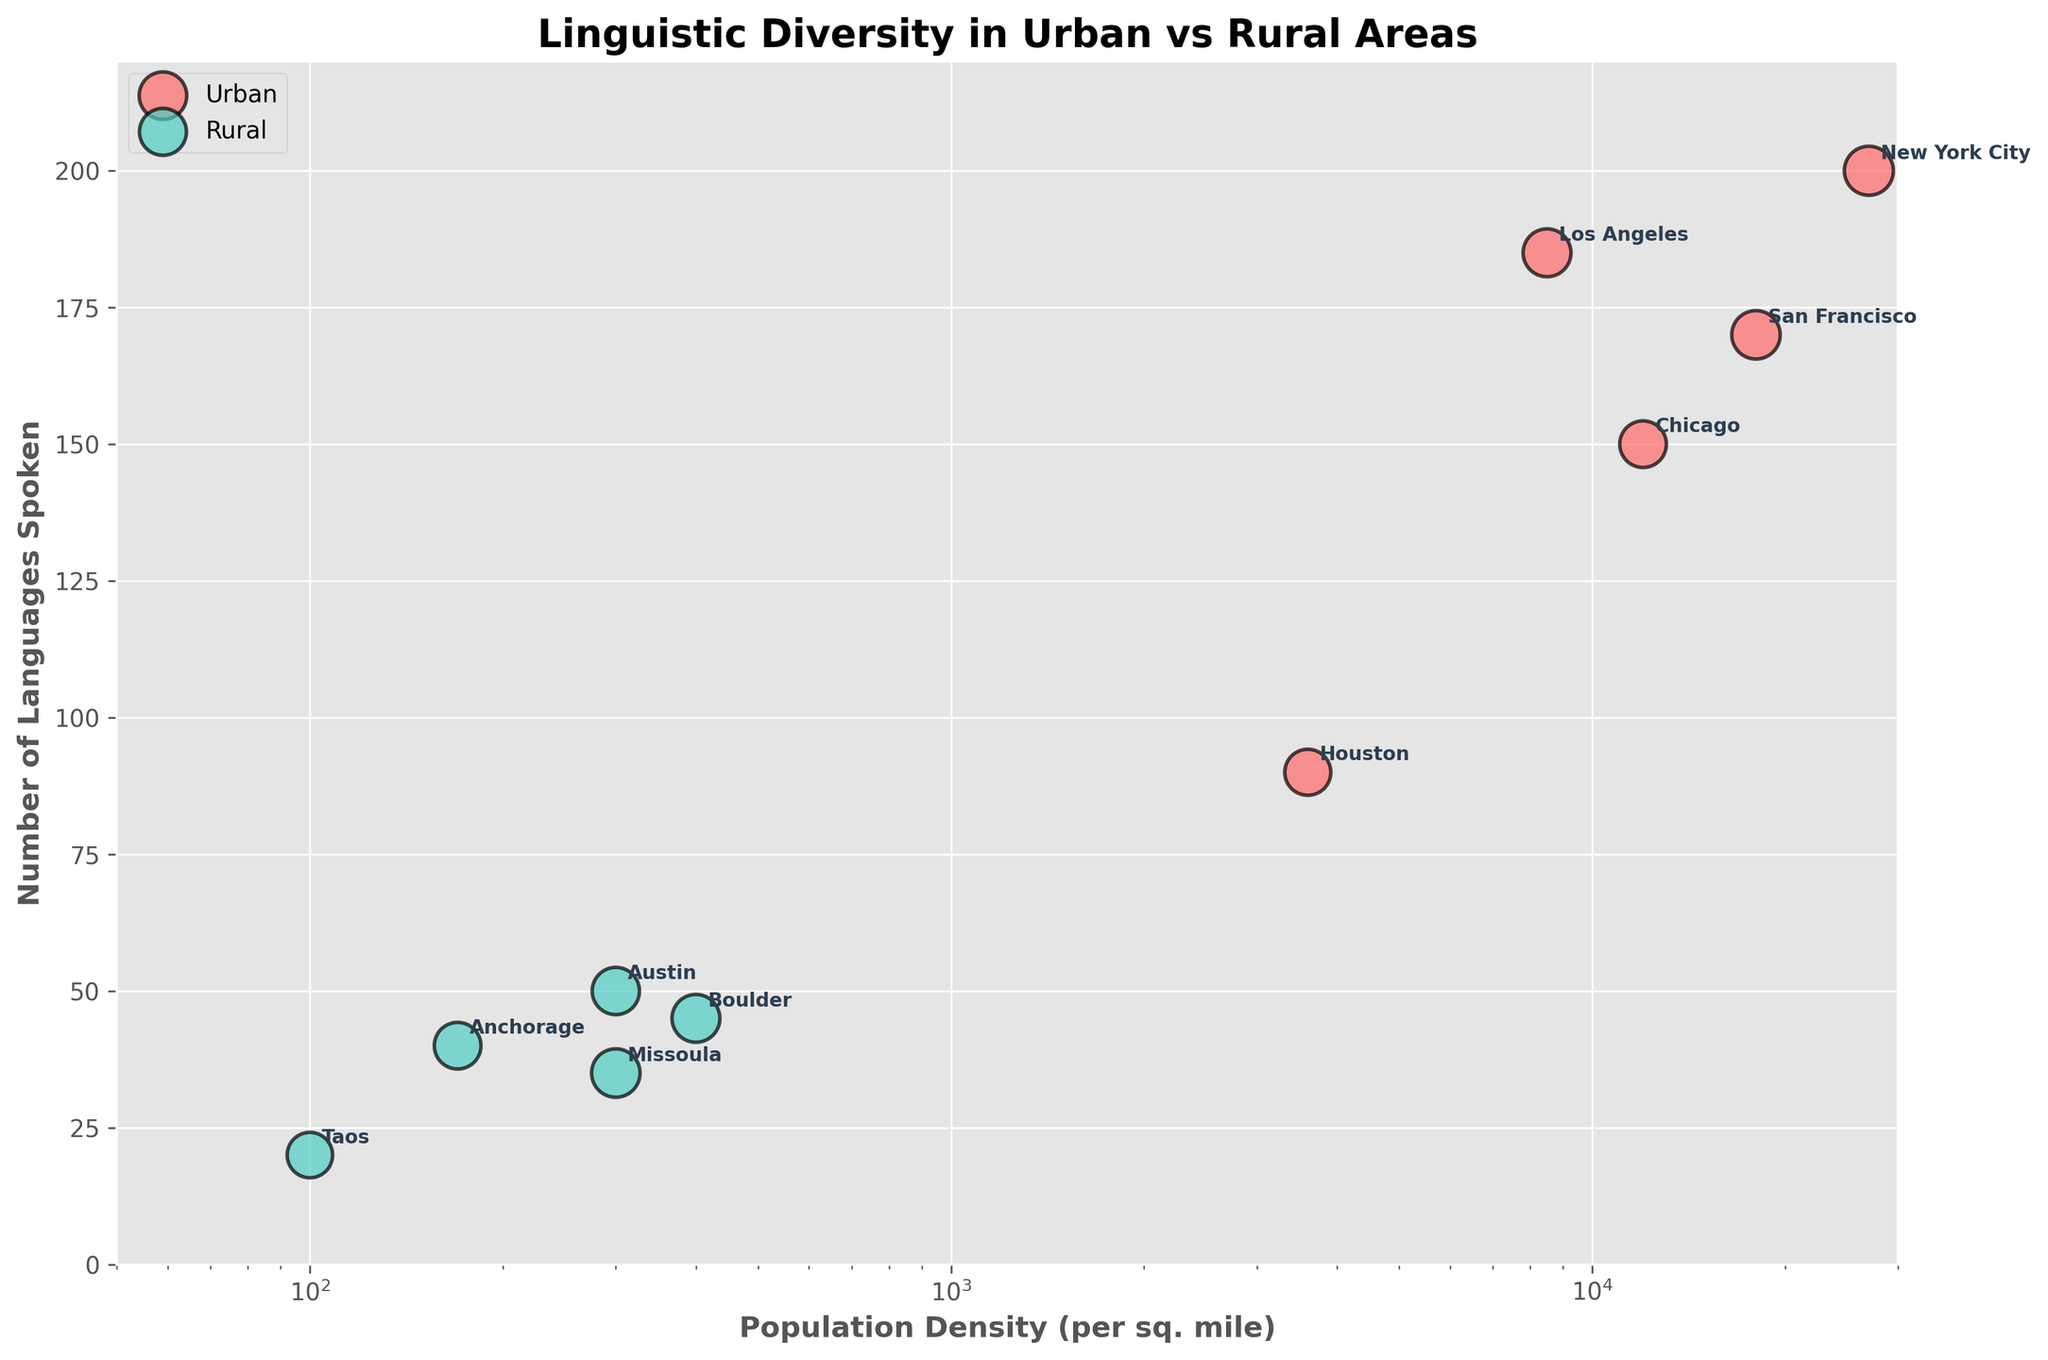What's the title of the figure? The title is the key text at the top of the figure, which summarizes its main topic. The title of this figure is "Linguistic Diversity in Urban vs Rural Areas".
Answer: Linguistic Diversity in Urban vs Rural Areas What are the two area types compared in the figure? The figure distinguishes between two types of regions by color. Red represents Urban areas, and green represents Rural areas.
Answer: Urban and Rural What is the population density range for Urban areas? To find this, locate the red bubbles and check their positions on the x-axis. The population density for Urban areas ranges from 3,600 to 27,000 per square mile.
Answer: 3,600 to 27,000 per sq. mile How many languages are spoken in Austin? Austin is marked with a green bubble and labeled on the plot. By locating Austin, we see it is plotted at 50 languages spoken.
Answer: 50 Which Urban area has the highest average language proficiency? Identify the urban bubbles (red) and check their corresponding sizes, which indicate language proficiency. The largest bubble among urban areas represents New York City, with an average language proficiency of 4.2.
Answer: New York City What's the difference in the number of languages spoken between the Urban area with the least and the most languages spoken? Compare the data points for Urban areas. Houston has the least languages spoken (90), and New York City has the most (200). The difference is 200 - 90 = 110.
Answer: 110 How does the population density of Chicago compare to Boulder? Chicago and Boulder are represented by different colors: red (Urban for Chicago) and green (Rural for Boulder). Chicago has a population density of 12,000 per sq. mile, while Boulder has 400 per sq. mile. Thus, Chicago’s population density is significantly higher than Boulder’s.
Answer: Chicago is higher For regions with a language proficiency of 4.0, which has the higher population density? Find regions with an average language proficiency of 4.0. Los Angeles (Urban) and Boulder (Rural) fit this criterion. Los Angeles has a higher population density (8500 per sq. mile) compared to Boulder (400 per sq. mile).
Answer: Los Angeles Is there a trend between population density and the number of languages spoken in Urban vs Rural areas? Observing the figure, densely populated Urban areas generally show a higher number of languages spoken than less densely populated Rural areas. This trend is visually apparent from the cluster of red bubbles towards higher values on both axes compared to green bubbles.
Answer: Higher density, more languages spoken in Urban 